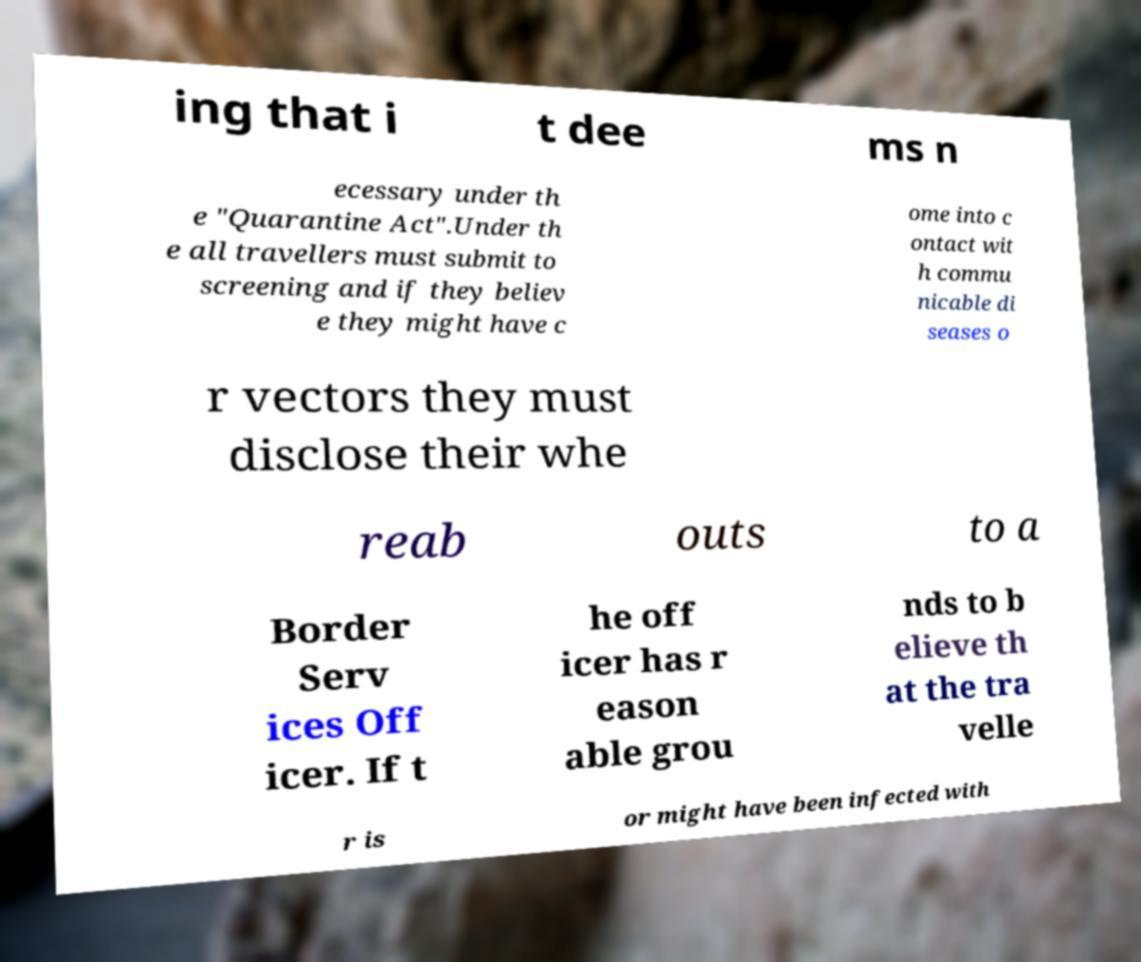Could you assist in decoding the text presented in this image and type it out clearly? ing that i t dee ms n ecessary under th e "Quarantine Act".Under th e all travellers must submit to screening and if they believ e they might have c ome into c ontact wit h commu nicable di seases o r vectors they must disclose their whe reab outs to a Border Serv ices Off icer. If t he off icer has r eason able grou nds to b elieve th at the tra velle r is or might have been infected with 